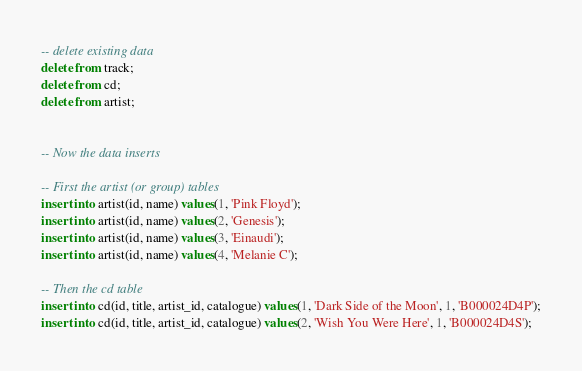Convert code to text. <code><loc_0><loc_0><loc_500><loc_500><_SQL_>-- delete existing data
delete from track;
delete from cd;
delete from artist;


-- Now the data inserts

-- First the artist (or group) tables 
insert into artist(id, name) values(1, 'Pink Floyd');
insert into artist(id, name) values(2, 'Genesis');
insert into artist(id, name) values(3, 'Einaudi');
insert into artist(id, name) values(4, 'Melanie C');

-- Then the cd table
insert into cd(id, title, artist_id, catalogue) values(1, 'Dark Side of the Moon', 1, 'B000024D4P');
insert into cd(id, title, artist_id, catalogue) values(2, 'Wish You Were Here', 1, 'B000024D4S');</code> 